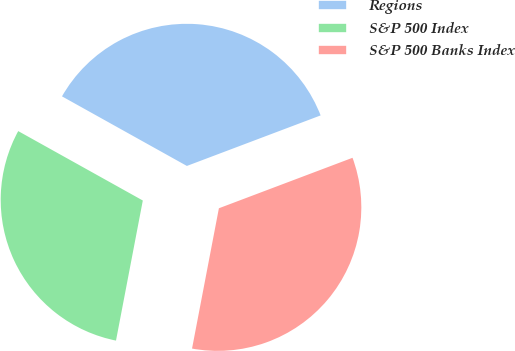Convert chart. <chart><loc_0><loc_0><loc_500><loc_500><pie_chart><fcel>Regions<fcel>S&P 500 Index<fcel>S&P 500 Banks Index<nl><fcel>36.16%<fcel>30.08%<fcel>33.76%<nl></chart> 